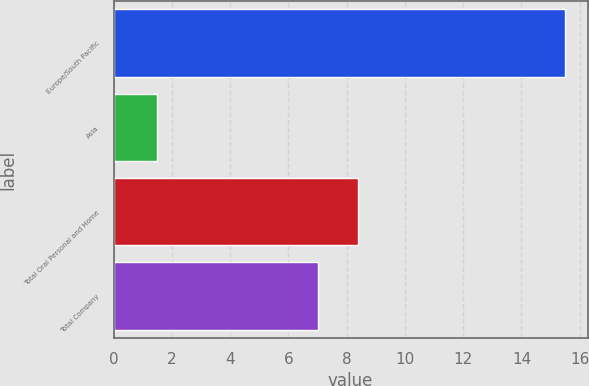Convert chart. <chart><loc_0><loc_0><loc_500><loc_500><bar_chart><fcel>Europe/South Pacific<fcel>Asia<fcel>Total Oral Personal and Home<fcel>Total Company<nl><fcel>15.5<fcel>1.5<fcel>8.4<fcel>7<nl></chart> 